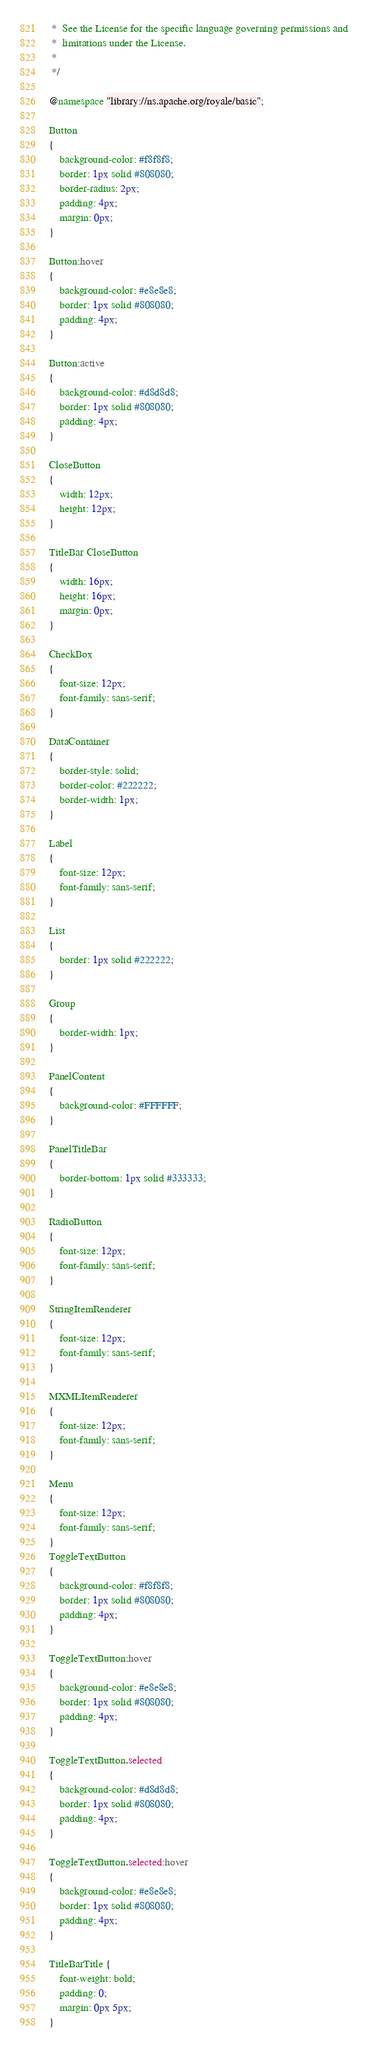Convert code to text. <code><loc_0><loc_0><loc_500><loc_500><_CSS_> *  See the License for the specific language governing permissions and
 *  limitations under the License.
 *
 */

@namespace "library://ns.apache.org/royale/basic";

Button
{
	background-color: #f8f8f8;
	border: 1px solid #808080;
	border-radius: 2px;
	padding: 4px;
	margin: 0px;
}

Button:hover
{
	background-color: #e8e8e8;
	border: 1px solid #808080;
	padding: 4px;
}

Button:active
{
	background-color: #d8d8d8;
	border: 1px solid #808080;
	padding: 4px;
}

CloseButton
{
	width: 12px;
	height: 12px;
}

TitleBar CloseButton
{
	width: 16px;
	height: 16px;
	margin: 0px;
}

CheckBox
{
	font-size: 12px;
	font-family: sans-serif;
}

DataContainer
{
	border-style: solid;
	border-color: #222222;
	border-width: 1px;
}

Label
{
	font-size: 12px;
	font-family: sans-serif;
}

List
{
	border: 1px solid #222222;
}

Group
{
	border-width: 1px;
}

PanelContent
{
	background-color: #FFFFFF;
}

PanelTitleBar
{
	border-bottom: 1px solid #333333;
}

RadioButton
{
	font-size: 12px;
	font-family: sans-serif;
}

StringItemRenderer
{
	font-size: 12px;
	font-family: sans-serif;
}

MXMLItemRenderer
{
	font-size: 12px;
	font-family: sans-serif;
}

Menu
{
	font-size: 12px;
	font-family: sans-serif;
}
ToggleTextButton
{
	background-color: #f8f8f8;
	border: 1px solid #808080;
	padding: 4px;
}

ToggleTextButton:hover
{
	background-color: #e8e8e8;
	border: 1px solid #808080;
	padding: 4px;
}

ToggleTextButton.selected
{
	background-color: #d8d8d8;
	border: 1px solid #808080;
	padding: 4px;
}

ToggleTextButton.selected:hover
{
	background-color: #e8e8e8;
	border: 1px solid #808080;
	padding: 4px;
}

TitleBarTitle {
	font-weight: bold;
	padding: 0;
	margin: 0px 5px;
}
</code> 